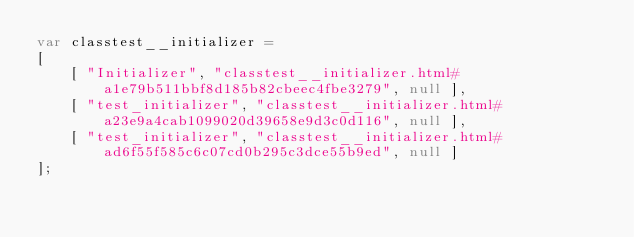Convert code to text. <code><loc_0><loc_0><loc_500><loc_500><_JavaScript_>var classtest__initializer =
[
    [ "Initializer", "classtest__initializer.html#a1e79b511bbf8d185b82cbeec4fbe3279", null ],
    [ "test_initializer", "classtest__initializer.html#a23e9a4cab1099020d39658e9d3c0d116", null ],
    [ "test_initializer", "classtest__initializer.html#ad6f55f585c6c07cd0b295c3dce55b9ed", null ]
];</code> 